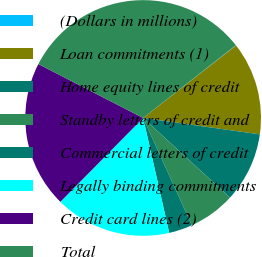<chart> <loc_0><loc_0><loc_500><loc_500><pie_chart><fcel>(Dollars in millions)<fcel>Loan commitments (1)<fcel>Home equity lines of credit<fcel>Standby letters of credit and<fcel>Commercial letters of credit<fcel>Legally binding commitments<fcel>Credit card lines (2)<fcel>Total<nl><fcel>0.05%<fcel>12.77%<fcel>9.59%<fcel>6.41%<fcel>3.23%<fcel>15.95%<fcel>20.17%<fcel>31.85%<nl></chart> 